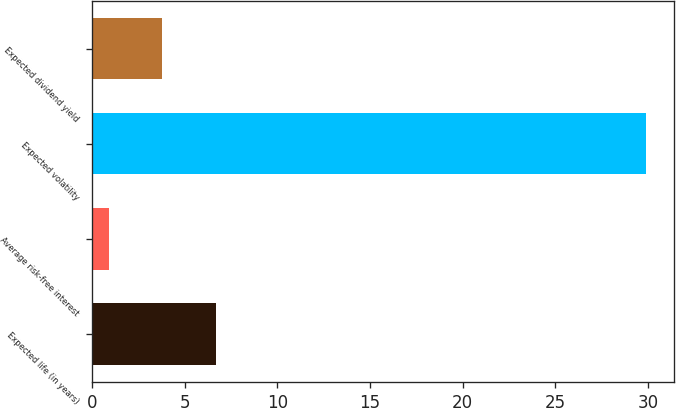Convert chart to OTSL. <chart><loc_0><loc_0><loc_500><loc_500><bar_chart><fcel>Expected life (in years)<fcel>Average risk-free interest<fcel>Expected volatility<fcel>Expected dividend yield<nl><fcel>6.7<fcel>0.9<fcel>29.9<fcel>3.8<nl></chart> 